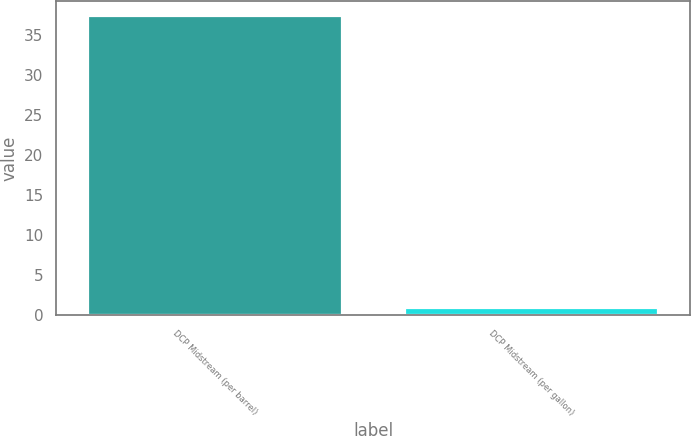Convert chart to OTSL. <chart><loc_0><loc_0><loc_500><loc_500><bar_chart><fcel>DCP Midstream (per barrel)<fcel>DCP Midstream (per gallon)<nl><fcel>37.43<fcel>0.89<nl></chart> 